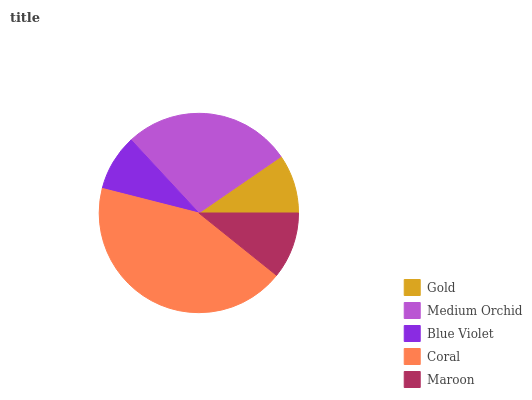Is Blue Violet the minimum?
Answer yes or no. Yes. Is Coral the maximum?
Answer yes or no. Yes. Is Medium Orchid the minimum?
Answer yes or no. No. Is Medium Orchid the maximum?
Answer yes or no. No. Is Medium Orchid greater than Gold?
Answer yes or no. Yes. Is Gold less than Medium Orchid?
Answer yes or no. Yes. Is Gold greater than Medium Orchid?
Answer yes or no. No. Is Medium Orchid less than Gold?
Answer yes or no. No. Is Maroon the high median?
Answer yes or no. Yes. Is Maroon the low median?
Answer yes or no. Yes. Is Blue Violet the high median?
Answer yes or no. No. Is Gold the low median?
Answer yes or no. No. 